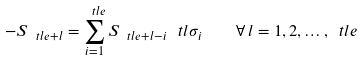<formula> <loc_0><loc_0><loc_500><loc_500>- S _ { \ t l { e } + l } = \sum _ { i = 1 } ^ { \ t l { e } } S _ { \ t l { e } + l - i } \, \ t l { \sigma } _ { i } \quad \forall \, l = 1 , 2 , \dots , \ t l { e }</formula> 